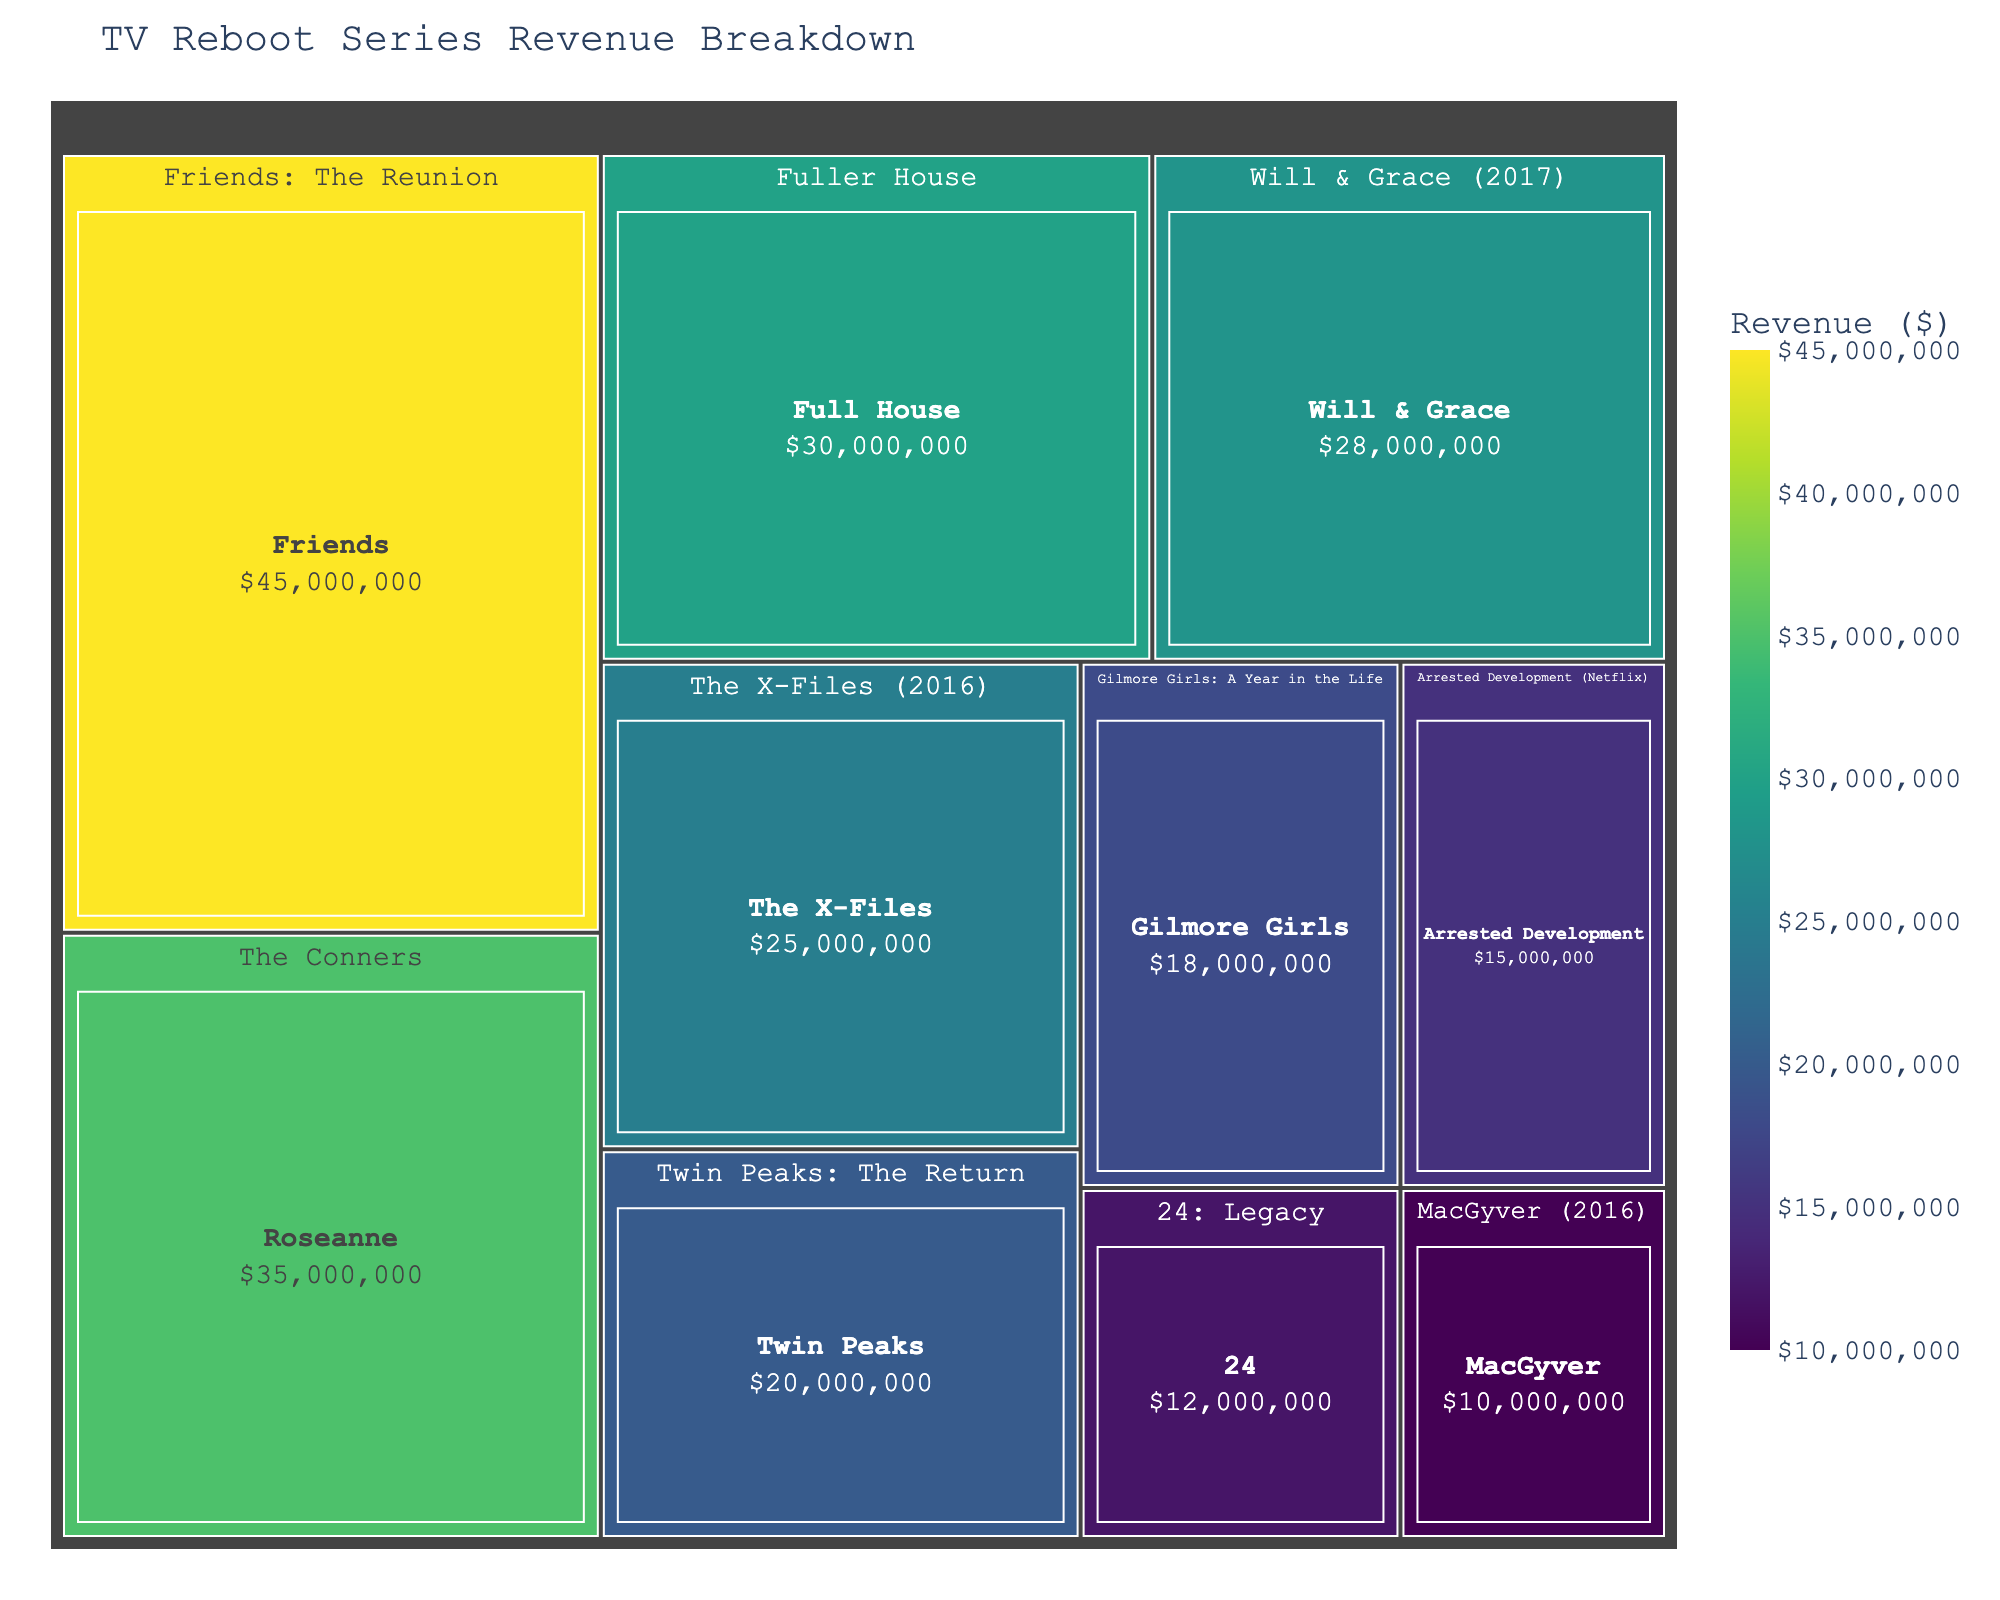What is the title of the treemap? The title is usually found at the top of the figure. In this case, it is displayed prominently above the chart.
Answer: TV Reboot Series Revenue Breakdown Which series generated the highest revenue? Look for the largest segment in the treemap that represents the highest revenue.
Answer: Friends: The Reunion What is the revenue of the series 'Fuller House'? Identify the segment labeled 'Fuller House' within the treemap. The revenue will be displayed within that segment or on hover.
Answer: $30,000,000 Compare the revenue of 'The Conners' to 'Will & Grace (2017)'. Which one is higher and by how much? Find both segments and note their respective revenues. Subtract the revenue of 'Will & Grace (2017)' from 'The Conners'.
Answer: 'The Conners' is higher by $7,000,000 Which reboot series has the smallest revenue and what is the amount? Locate the smallest segment, as it represents the lowest revenue in the treemap.
Answer: MacGyver (2016) with $10,000,000 What is the total revenue of all series combined? Add the revenues of all segments shown in the treemap. Explanation continues below.
   45,000,000 + 35,000,000 + 30,000,000 + 28,000,000 + 25,000,000 + 20,000,000 + 18,000,000 + 15,000,000 + 12,000,000 + 10,000,000 = 238,000,000
Answer: $238,000,000 Compare the total revenue of all series whose original aired in the 90s to those from the 80s and determine which decade had the highest combined revenue. To answer this, first identify which series originally aired during those decades:
90s: Friends: The Reunion, Will & Grace (2017), The X-Files (2016), Twin Peaks: The Return, Gilmore Girls: A Year in the Life, 
80s: The Conners, Twin Peaks: The Return (consider overlap), MacGyver (2016),
Sum the revenues of each group:
- 90s: 45,000,000 + 28,000,000 + 25,000,000 + 20,000,000 + 18,000,000 = 136,000,000 
- 80s: 35,000,000 + 10,000,000 = 45,000,000
The total revenue of the 90s is higher.
Answer: 90s with $136,000,000 Which reboot series has a closer revenue to 'Fuller House', 'Arrested Development (Netflix)', or 'Gilmore Girls: A Year in the Life'? Compare the revenues of 'Arrested Development (Netflix)' and 'Gilmore Girls: A Year in the Life' with 'Fuller House'.
- Fuller House: $30,000,000
- Arrested Development (Netflix): $15,000,000
- Gilmore Girls: A Year in the Life: $18,000,000
'Gilmore Girls: A Year in the Life' is closer to $30,000,000 than 'Arrested Development'.
Answer: 'Gilmore Girls: A Year in the Life' How does the revenue of 'Twin Peaks: The Return' compare to the median revenue of all the series? List all revenues: 
45,000,000, 35,000,000, 30,000,000, 28,000,000, 25,000,000, 20,000,000, 18,000,000, 15,000,000, 12,000,000, 10,000,000 
The median value is the middle value in an ordered list, which in this case:
20,000,000 is the median since the list has an average of the middle two values for an even count.
Compare 'Twin Peaks: The Return' which has $20,000,000 to this median value.
Answer: It is equal to the median value 